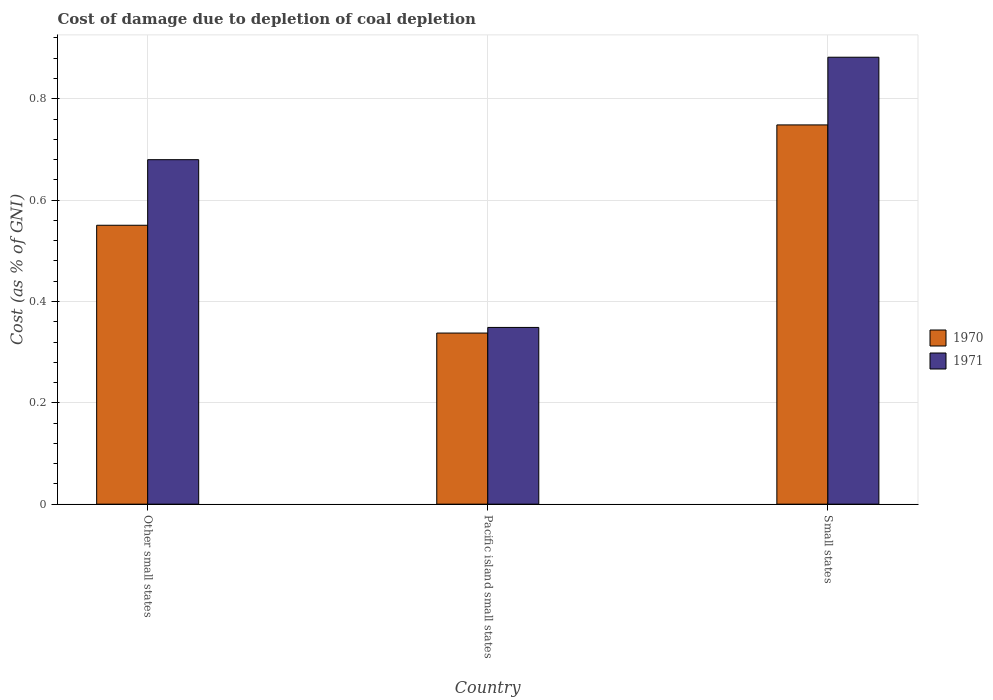How many groups of bars are there?
Keep it short and to the point. 3. Are the number of bars per tick equal to the number of legend labels?
Offer a very short reply. Yes. What is the label of the 2nd group of bars from the left?
Ensure brevity in your answer.  Pacific island small states. What is the cost of damage caused due to coal depletion in 1970 in Small states?
Ensure brevity in your answer.  0.75. Across all countries, what is the maximum cost of damage caused due to coal depletion in 1970?
Provide a succinct answer. 0.75. Across all countries, what is the minimum cost of damage caused due to coal depletion in 1971?
Your answer should be very brief. 0.35. In which country was the cost of damage caused due to coal depletion in 1971 maximum?
Your response must be concise. Small states. In which country was the cost of damage caused due to coal depletion in 1971 minimum?
Make the answer very short. Pacific island small states. What is the total cost of damage caused due to coal depletion in 1971 in the graph?
Provide a short and direct response. 1.91. What is the difference between the cost of damage caused due to coal depletion in 1971 in Other small states and that in Pacific island small states?
Ensure brevity in your answer.  0.33. What is the difference between the cost of damage caused due to coal depletion in 1970 in Other small states and the cost of damage caused due to coal depletion in 1971 in Pacific island small states?
Your response must be concise. 0.2. What is the average cost of damage caused due to coal depletion in 1970 per country?
Your answer should be compact. 0.55. What is the difference between the cost of damage caused due to coal depletion of/in 1971 and cost of damage caused due to coal depletion of/in 1970 in Pacific island small states?
Your answer should be very brief. 0.01. What is the ratio of the cost of damage caused due to coal depletion in 1970 in Other small states to that in Pacific island small states?
Your response must be concise. 1.63. Is the cost of damage caused due to coal depletion in 1970 in Pacific island small states less than that in Small states?
Make the answer very short. Yes. What is the difference between the highest and the second highest cost of damage caused due to coal depletion in 1970?
Offer a very short reply. 0.2. What is the difference between the highest and the lowest cost of damage caused due to coal depletion in 1970?
Your answer should be compact. 0.41. In how many countries, is the cost of damage caused due to coal depletion in 1971 greater than the average cost of damage caused due to coal depletion in 1971 taken over all countries?
Keep it short and to the point. 2. How many bars are there?
Your response must be concise. 6. What is the difference between two consecutive major ticks on the Y-axis?
Provide a succinct answer. 0.2. Does the graph contain grids?
Keep it short and to the point. Yes. Where does the legend appear in the graph?
Your answer should be compact. Center right. How many legend labels are there?
Offer a very short reply. 2. What is the title of the graph?
Make the answer very short. Cost of damage due to depletion of coal depletion. What is the label or title of the Y-axis?
Provide a short and direct response. Cost (as % of GNI). What is the Cost (as % of GNI) of 1970 in Other small states?
Offer a terse response. 0.55. What is the Cost (as % of GNI) of 1971 in Other small states?
Give a very brief answer. 0.68. What is the Cost (as % of GNI) in 1970 in Pacific island small states?
Give a very brief answer. 0.34. What is the Cost (as % of GNI) in 1971 in Pacific island small states?
Keep it short and to the point. 0.35. What is the Cost (as % of GNI) in 1970 in Small states?
Your answer should be very brief. 0.75. What is the Cost (as % of GNI) of 1971 in Small states?
Give a very brief answer. 0.88. Across all countries, what is the maximum Cost (as % of GNI) in 1970?
Your answer should be very brief. 0.75. Across all countries, what is the maximum Cost (as % of GNI) in 1971?
Make the answer very short. 0.88. Across all countries, what is the minimum Cost (as % of GNI) in 1970?
Provide a succinct answer. 0.34. Across all countries, what is the minimum Cost (as % of GNI) of 1971?
Your answer should be very brief. 0.35. What is the total Cost (as % of GNI) in 1970 in the graph?
Provide a short and direct response. 1.64. What is the total Cost (as % of GNI) of 1971 in the graph?
Your answer should be very brief. 1.91. What is the difference between the Cost (as % of GNI) of 1970 in Other small states and that in Pacific island small states?
Give a very brief answer. 0.21. What is the difference between the Cost (as % of GNI) of 1971 in Other small states and that in Pacific island small states?
Offer a very short reply. 0.33. What is the difference between the Cost (as % of GNI) of 1970 in Other small states and that in Small states?
Provide a succinct answer. -0.2. What is the difference between the Cost (as % of GNI) of 1971 in Other small states and that in Small states?
Give a very brief answer. -0.2. What is the difference between the Cost (as % of GNI) in 1970 in Pacific island small states and that in Small states?
Offer a terse response. -0.41. What is the difference between the Cost (as % of GNI) in 1971 in Pacific island small states and that in Small states?
Make the answer very short. -0.53. What is the difference between the Cost (as % of GNI) in 1970 in Other small states and the Cost (as % of GNI) in 1971 in Pacific island small states?
Give a very brief answer. 0.2. What is the difference between the Cost (as % of GNI) in 1970 in Other small states and the Cost (as % of GNI) in 1971 in Small states?
Ensure brevity in your answer.  -0.33. What is the difference between the Cost (as % of GNI) of 1970 in Pacific island small states and the Cost (as % of GNI) of 1971 in Small states?
Your answer should be very brief. -0.54. What is the average Cost (as % of GNI) of 1970 per country?
Your response must be concise. 0.55. What is the average Cost (as % of GNI) of 1971 per country?
Ensure brevity in your answer.  0.64. What is the difference between the Cost (as % of GNI) of 1970 and Cost (as % of GNI) of 1971 in Other small states?
Give a very brief answer. -0.13. What is the difference between the Cost (as % of GNI) of 1970 and Cost (as % of GNI) of 1971 in Pacific island small states?
Your answer should be compact. -0.01. What is the difference between the Cost (as % of GNI) of 1970 and Cost (as % of GNI) of 1971 in Small states?
Provide a succinct answer. -0.13. What is the ratio of the Cost (as % of GNI) of 1970 in Other small states to that in Pacific island small states?
Your response must be concise. 1.63. What is the ratio of the Cost (as % of GNI) of 1971 in Other small states to that in Pacific island small states?
Provide a short and direct response. 1.95. What is the ratio of the Cost (as % of GNI) in 1970 in Other small states to that in Small states?
Make the answer very short. 0.74. What is the ratio of the Cost (as % of GNI) of 1971 in Other small states to that in Small states?
Give a very brief answer. 0.77. What is the ratio of the Cost (as % of GNI) of 1970 in Pacific island small states to that in Small states?
Your response must be concise. 0.45. What is the ratio of the Cost (as % of GNI) of 1971 in Pacific island small states to that in Small states?
Your response must be concise. 0.4. What is the difference between the highest and the second highest Cost (as % of GNI) of 1970?
Your answer should be compact. 0.2. What is the difference between the highest and the second highest Cost (as % of GNI) in 1971?
Offer a very short reply. 0.2. What is the difference between the highest and the lowest Cost (as % of GNI) of 1970?
Offer a very short reply. 0.41. What is the difference between the highest and the lowest Cost (as % of GNI) in 1971?
Your answer should be compact. 0.53. 